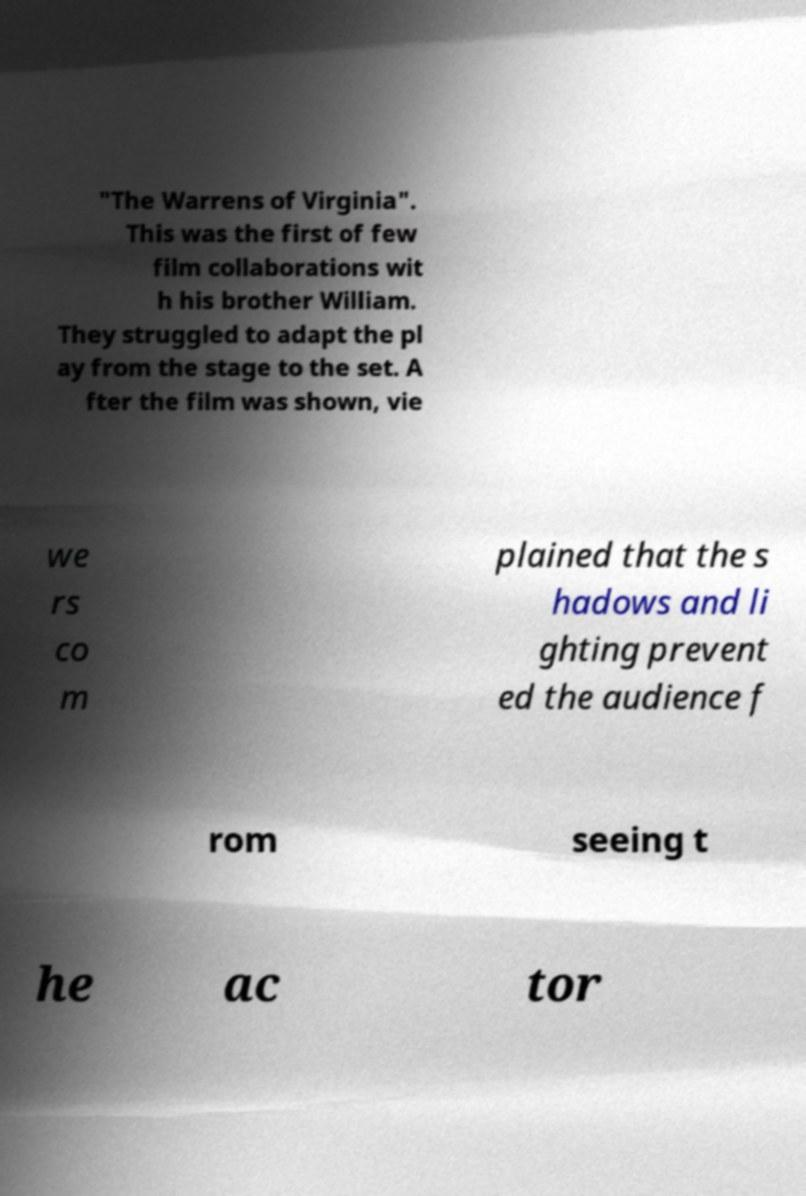Please identify and transcribe the text found in this image. "The Warrens of Virginia". This was the first of few film collaborations wit h his brother William. They struggled to adapt the pl ay from the stage to the set. A fter the film was shown, vie we rs co m plained that the s hadows and li ghting prevent ed the audience f rom seeing t he ac tor 